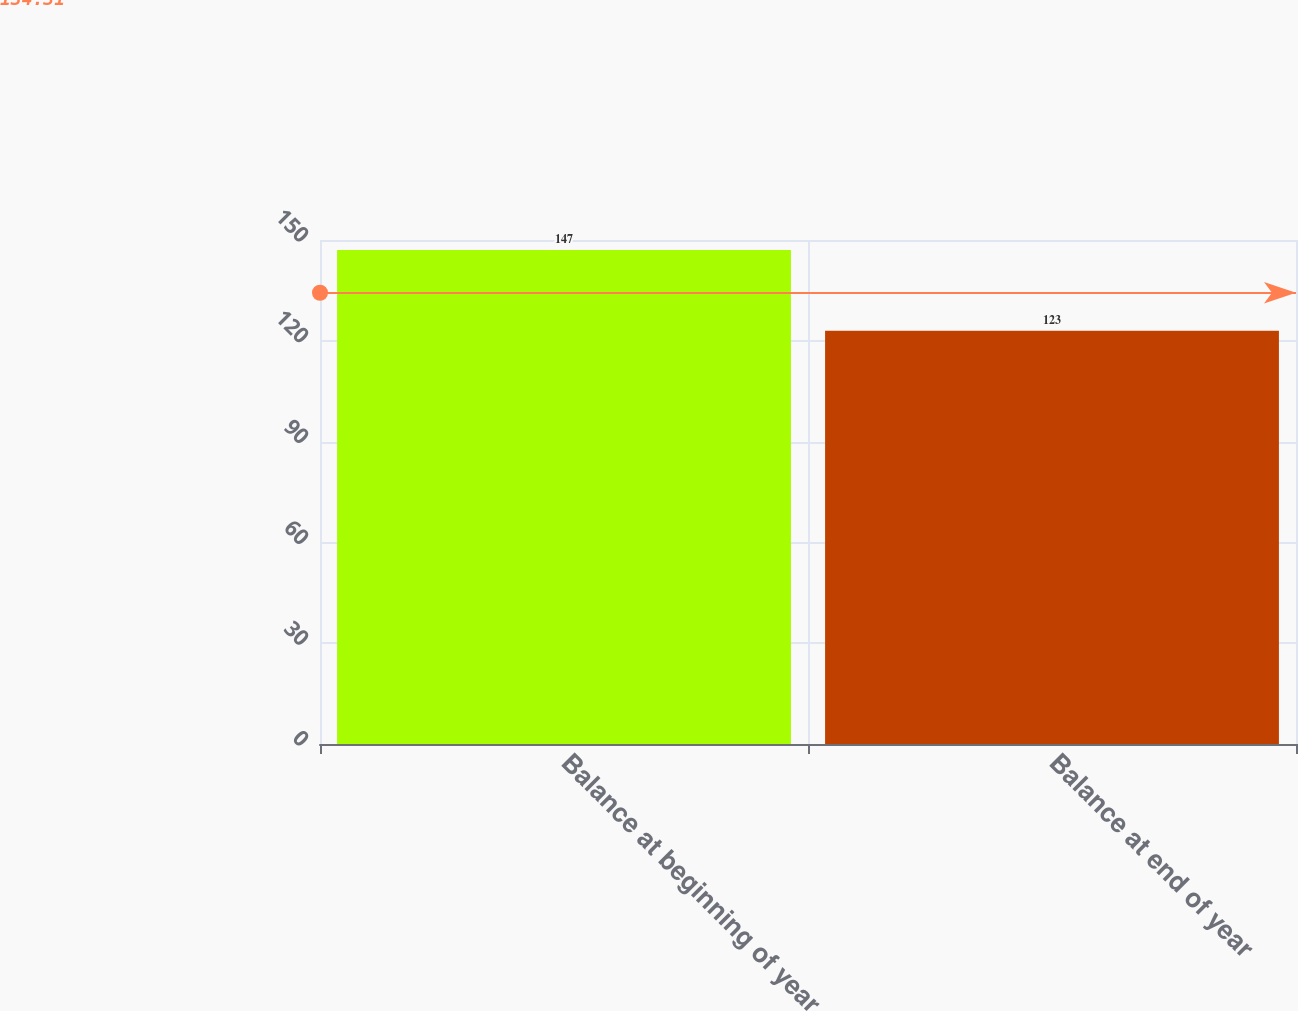Convert chart to OTSL. <chart><loc_0><loc_0><loc_500><loc_500><bar_chart><fcel>Balance at beginning of year<fcel>Balance at end of year<nl><fcel>147<fcel>123<nl></chart> 